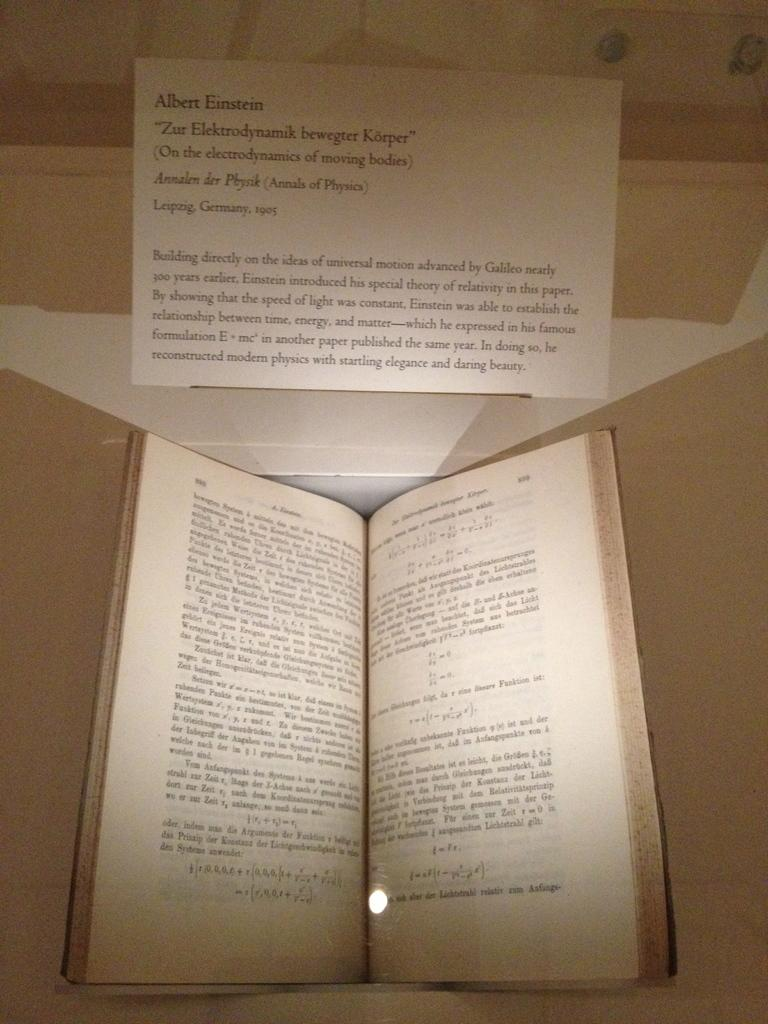<image>
Create a compact narrative representing the image presented. a book is open with an albert einstein quote over it 